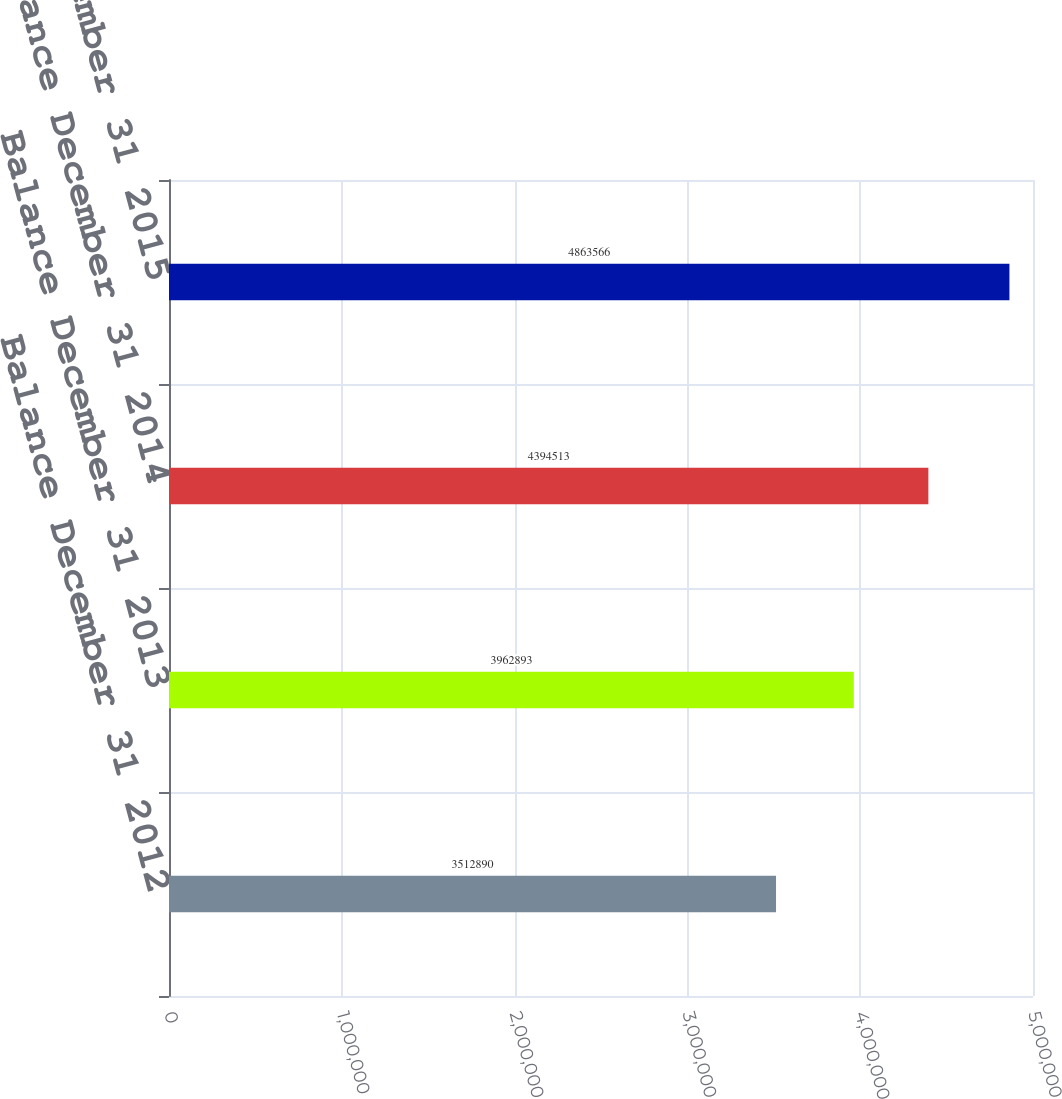<chart> <loc_0><loc_0><loc_500><loc_500><bar_chart><fcel>Balance December 31 2012<fcel>Balance December 31 2013<fcel>Balance December 31 2014<fcel>Balance December 31 2015<nl><fcel>3.51289e+06<fcel>3.96289e+06<fcel>4.39451e+06<fcel>4.86357e+06<nl></chart> 